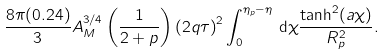Convert formula to latex. <formula><loc_0><loc_0><loc_500><loc_500>\frac { 8 \pi ( 0 . 2 4 ) } { 3 } A _ { M } ^ { 3 / 4 } \left ( \frac { 1 } { 2 + p } \right ) \left ( 2 q \tau \right ) ^ { 2 } \int _ { 0 } ^ { \eta _ { p } - \eta } \, { \mathrm d } \chi \frac { \tanh ^ { 2 } ( a \chi ) } { R _ { p } ^ { 2 } } .</formula> 